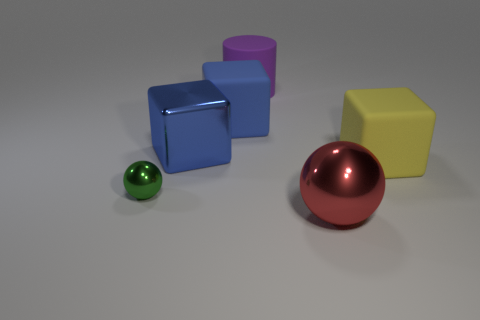What is the shape of the large matte thing that is the same color as the metallic block?
Provide a succinct answer. Cube. Does the big block behind the blue metallic thing have the same color as the large metal cube?
Keep it short and to the point. Yes. What is the color of the object that is in front of the yellow rubber thing and to the right of the big rubber cylinder?
Keep it short and to the point. Red. The blue shiny object that is the same size as the red metal ball is what shape?
Ensure brevity in your answer.  Cube. Is there a rubber block of the same color as the metal block?
Your answer should be compact. Yes. Are there an equal number of red objects that are to the right of the big red sphere and big red things?
Offer a terse response. No. There is a metallic object that is both in front of the yellow rubber cube and on the left side of the big red shiny object; how big is it?
Your response must be concise. Small. What is the color of the cylinder that is made of the same material as the big yellow thing?
Your answer should be compact. Purple. How many other big red objects are the same material as the red thing?
Provide a short and direct response. 0. Are there an equal number of tiny balls to the right of the tiny shiny sphere and big spheres behind the big metal sphere?
Offer a very short reply. Yes. 